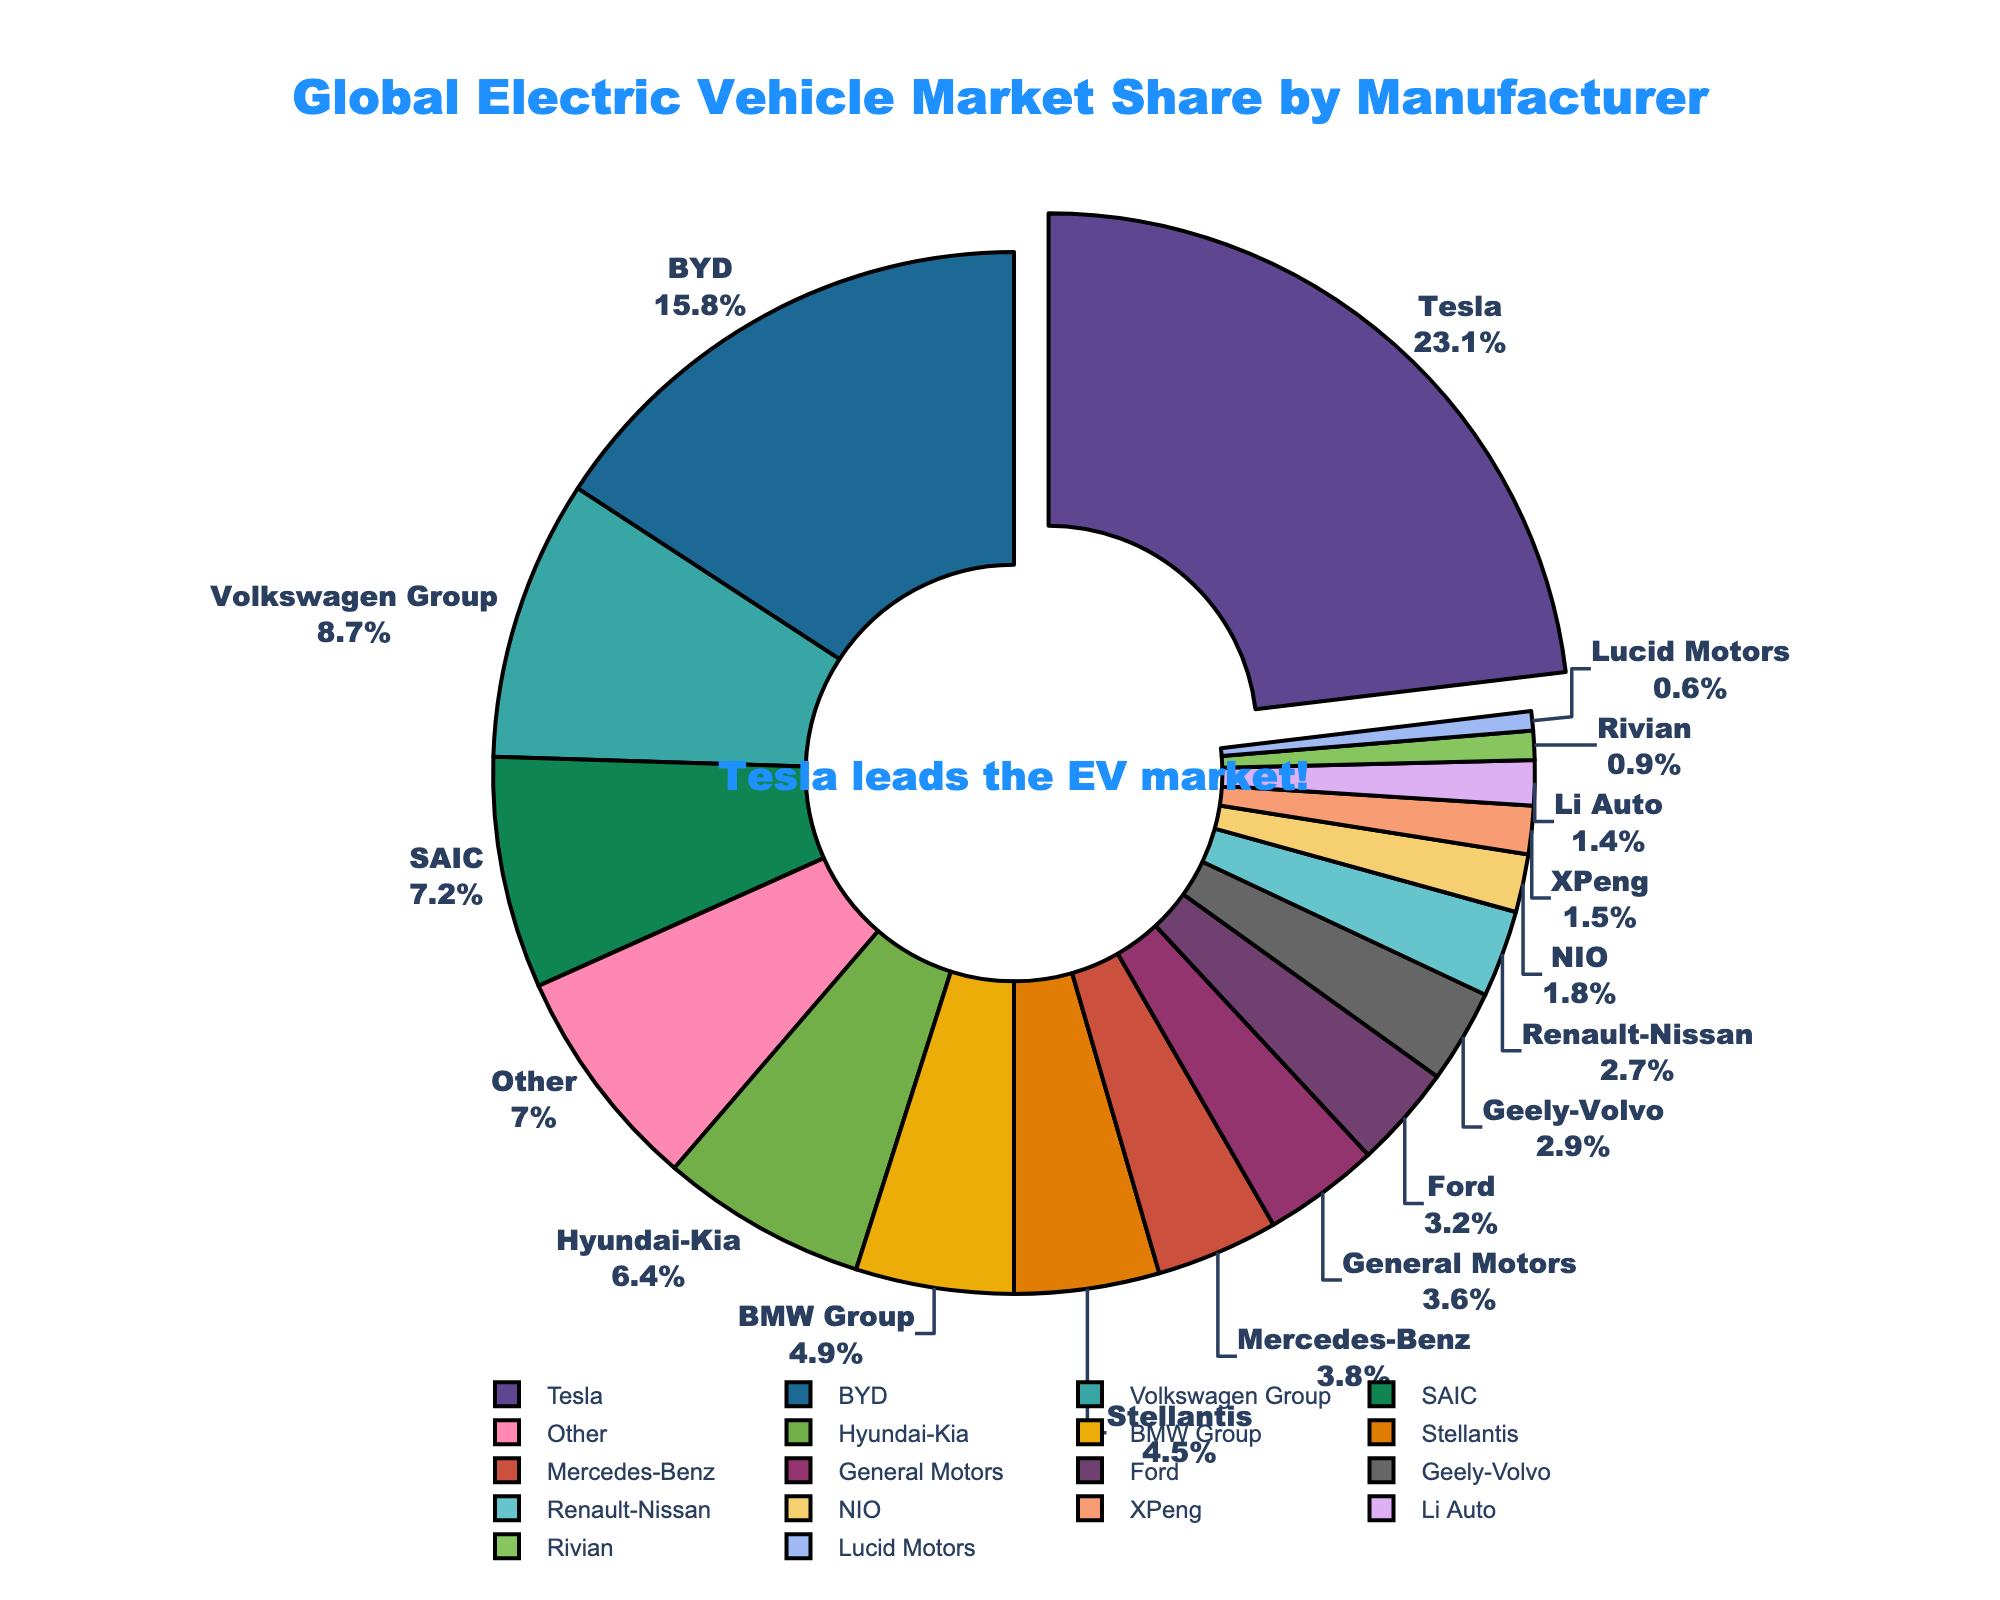What is the total market share of the top three manufacturers? To find the total market share of the top three manufacturers, sum the market shares of Tesla, BYD, and Volkswagen Group. Tesla has 23.1%, BYD has 15.8%, and Volkswagen Group has 8.7%. Adding these together: 23.1 + 15.8 + 8.7 = 47.6
Answer: 47.6% Which manufacturer has the second largest market share and what is that share? To determine the manufacturer with the second largest market share, look for the manufacturer with the highest share after Tesla. Tesla has 23.1%, and BYD has the next largest share at 15.8%.
Answer: BYD, 15.8% How much greater is Tesla's market share compared to Hyundai-Kia? Calculate the difference between Tesla's market share and Hyundai-Kia's market share. Tesla has a 23.1% share, and Hyundai-Kia has a 6.4% share. 23.1 - 6.4 = 16.7
Answer: 16.7 What is the combined market share of manufacturers with less than 2% of the market share each? Sum the market shares of NIO, XPeng, Li Auto, Rivian, and Lucid Motors, which are all below 2%. NIO has 1.8%, XPeng has 1.5%, Li Auto has 1.4%, Rivian has 0.9%, and Lucid Motors has 0.6%. Adding these together: 1.8 + 1.5 + 1.4 + 0.9 + 0.6 = 6.2
Answer: 6.2 Which manufacturer has a market share closest to 4%? Compare the market shares around 4%. BMW Group has 4.9%, Stellantis has 4.5%, and Mercedes-Benz has 3.8%. Among these, Mercedes-Benz's 3.8% is the closest to 4%.
Answer: Mercedes-Benz How does the market share of 'Other' compare to General Motors and Ford combined? Sum the market shares of General Motors and Ford then compare it to 'Other'. General Motors has 3.6%, and Ford has 3.2%. Their combined share is 3.6 + 3.2 = 6.8%. 'Other' has a market share of 7.0%, which is slightly higher than the combined share of General Motors and Ford.
Answer: 'Other' is greater What is the average market share of the manufacturers Volkswagen Group, Hyundai-Kia, and BMW Group? Calculate the average by summing their market shares and dividing by the number of manufacturers. Volkswagen Group has 8.7%, Hyundai-Kia has 6.4%, and BMW Group has 4.9%. Sum their shares: 8.7 + 6.4 + 4.9 = 20. Then divide by 3: 20 / 3 ≈ 6.67
Answer: 6.67 Which manufacturers have a market share larger than 5% but less than 10%? Identify manufacturers within this range. Volkswagen Group has 8.7%, and Hyundai-Kia has 6.4%. Both of them meet the criteria.
Answer: Volkswagen Group, Hyundai-Kia What percentage of the market is made up of manufacturers with a market share under 5%? Add the market shares of manufacturers with less than 5% individually. These are BMW Group (4.9%), Stellantis (4.5%), Mercedes-Benz (3.8%), General Motors (3.6%), Ford (3.2%), Geely-Volvo (2.9%), Renault-Nissan (2.7%), NIO (1.8%), XPeng (1.5%), Li Auto (1.4%), Rivian (0.9%), and Lucid Motors (0.6%). Summing these: 4.9 + 4.5 + 3.8 + 3.6 + 3.2 + 2.9 + 2.7 + 1.8 + 1.5 + 1.4 + 0.9 + 0.6 = 31.8
Answer: 31.8 